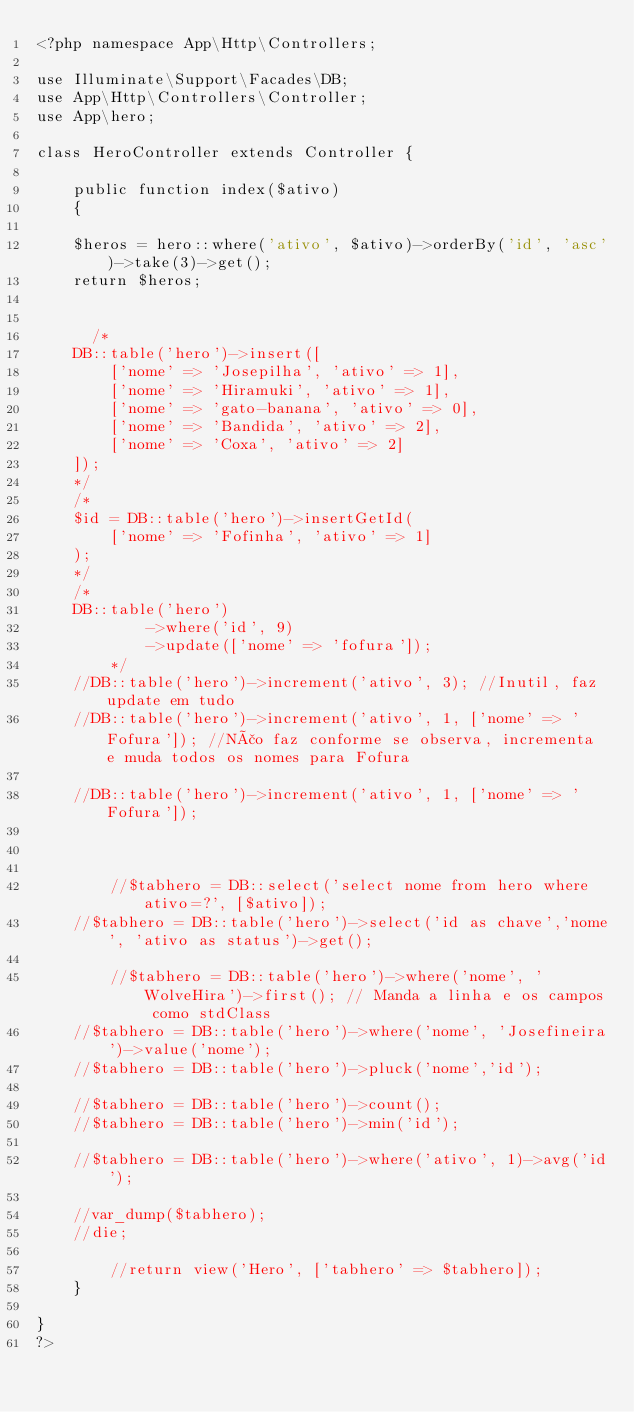Convert code to text. <code><loc_0><loc_0><loc_500><loc_500><_PHP_><?php namespace App\Http\Controllers;

use Illuminate\Support\Facades\DB;
use App\Http\Controllers\Controller;
use App\hero;

class HeroController extends Controller {

    public function index($ativo)
    {

		$heros = hero::where('ativo', $ativo)->orderBy('id', 'asc')->take(3)->get();
		return $heros;


    	/*
		DB::table('hero')->insert([
		    ['nome' => 'Josepilha', 'ativo' => 1],
		    ['nome' => 'Hiramuki', 'ativo' => 1],
		    ['nome' => 'gato-banana', 'ativo' => 0],
		    ['nome' => 'Bandida', 'ativo' => 2],
		    ['nome' => 'Coxa', 'ativo' => 2]
		]);
		*/
		/*
		$id = DB::table('hero')->insertGetId(
    		['nome' => 'Fofinha', 'ativo' => 1]
		);
		*/
		/*
		DB::table('hero')
            ->where('id', 9)
            ->update(['nome' => 'fofura']);
        */
		//DB::table('hero')->increment('ativo', 3); //Inutil, faz update em tudo
		//DB::table('hero')->increment('ativo', 1, ['nome' => 'Fofura']); //Não faz conforme se observa, incrementa e muda todos os nomes para Fofura

		//DB::table('hero')->increment('ativo', 1, ['nome' => 'Fofura']);

		

        //$tabhero = DB::select('select nome from hero where ativo=?', [$ativo]);     
		//$tabhero = DB::table('hero')->select('id as chave','nome', 'ativo as status')->get();

        //$tabhero = DB::table('hero')->where('nome', 'WolveHira')->first(); // Manda a linha e os campos como stdClass
		//$tabhero = DB::table('hero')->where('nome', 'Josefineira')->value('nome');
		//$tabhero = DB::table('hero')->pluck('nome','id');

		//$tabhero = DB::table('hero')->count();
		//$tabhero = DB::table('hero')->min('id');

		//$tabhero = DB::table('hero')->where('ativo', 1)->avg('id');

		//var_dump($tabhero);
		//die;

        //return view('Hero', ['tabhero' => $tabhero]);
    }

}
?>
</code> 